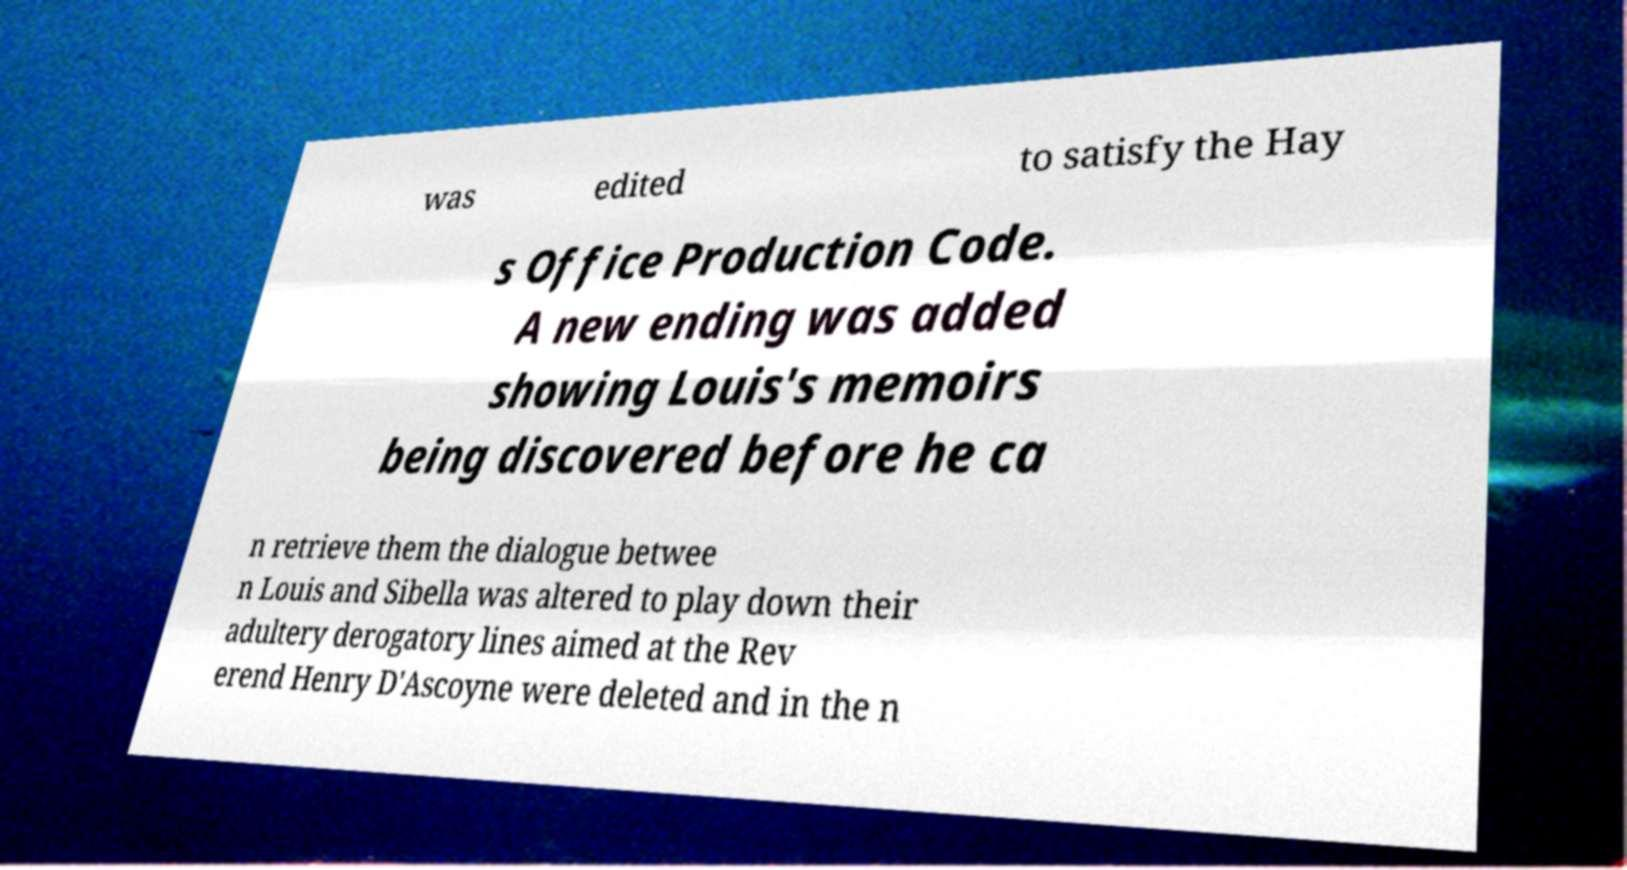Please read and relay the text visible in this image. What does it say? was edited to satisfy the Hay s Office Production Code. A new ending was added showing Louis's memoirs being discovered before he ca n retrieve them the dialogue betwee n Louis and Sibella was altered to play down their adultery derogatory lines aimed at the Rev erend Henry D'Ascoyne were deleted and in the n 